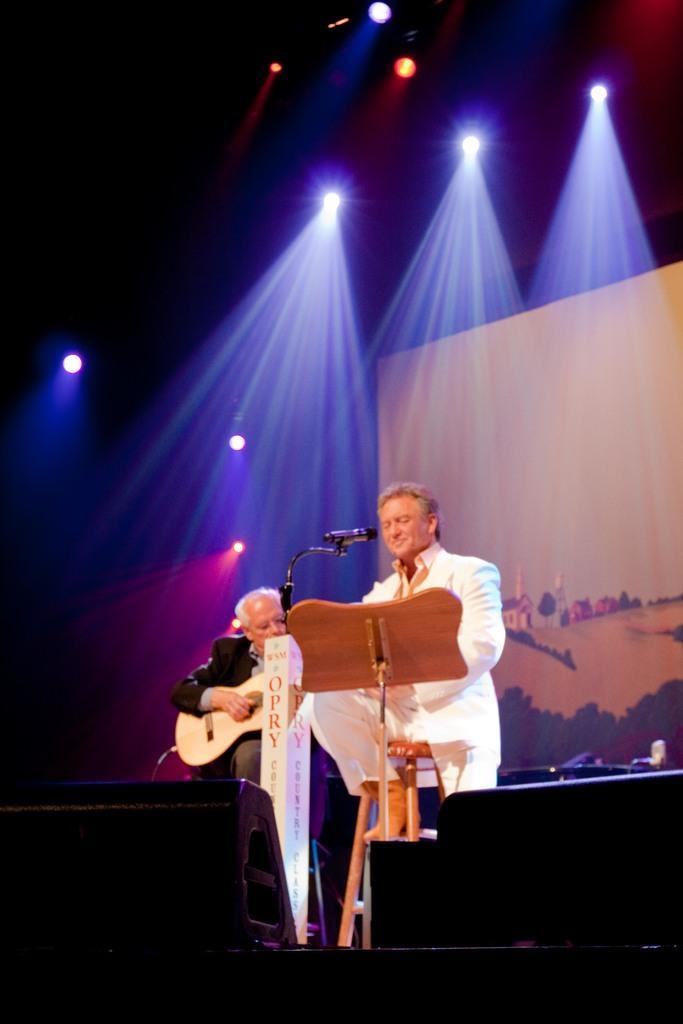Could you give a brief overview of what you see in this image? It looks like a music show there are two people in the image one person is wearing white color dress another person is wearing black color ,the person who is wearing black color dress is holding a guitar a person wearing white color dress is speaking something, in the background there is projector ,some lights. 